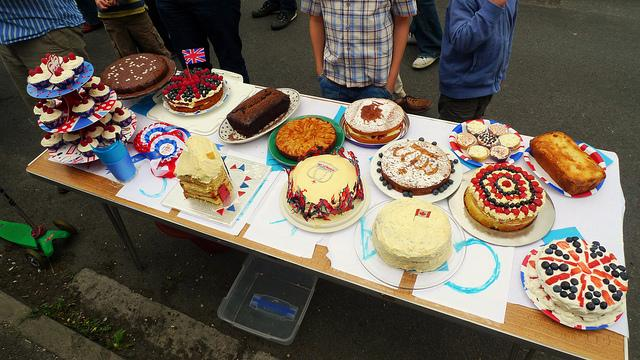The flag of what country is placed in the berry cake? england 